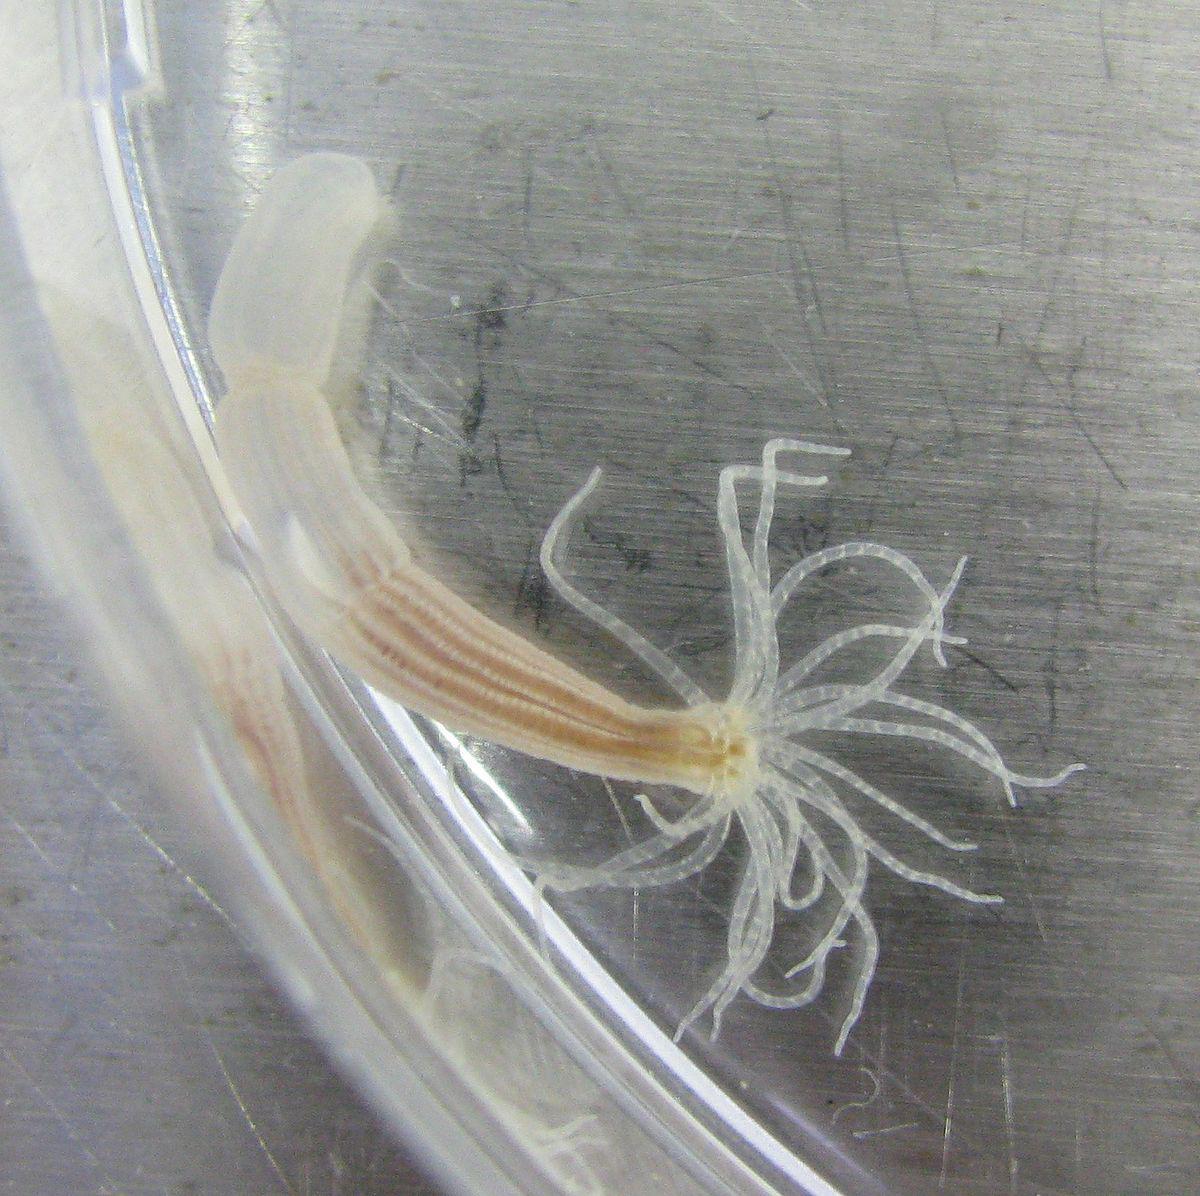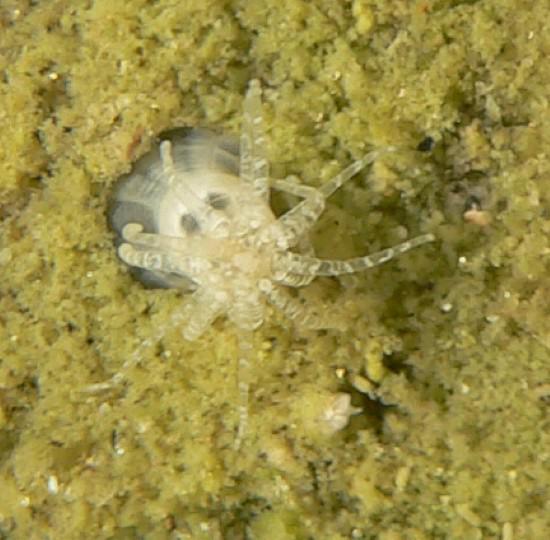The first image is the image on the left, the second image is the image on the right. Examine the images to the left and right. Is the description "Each image shows only a single living organism." accurate? Answer yes or no. Yes. 